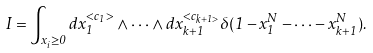<formula> <loc_0><loc_0><loc_500><loc_500>I = \int _ { x _ { i } \geq 0 } d x _ { 1 } ^ { < c _ { 1 } > } \wedge \cdot \cdot \cdot \wedge d x _ { k + 1 } ^ { < c _ { k + 1 > } } \delta ( 1 - x _ { 1 } ^ { N } - \cdot \cdot \cdot - x _ { k + 1 } ^ { N } ) .</formula> 